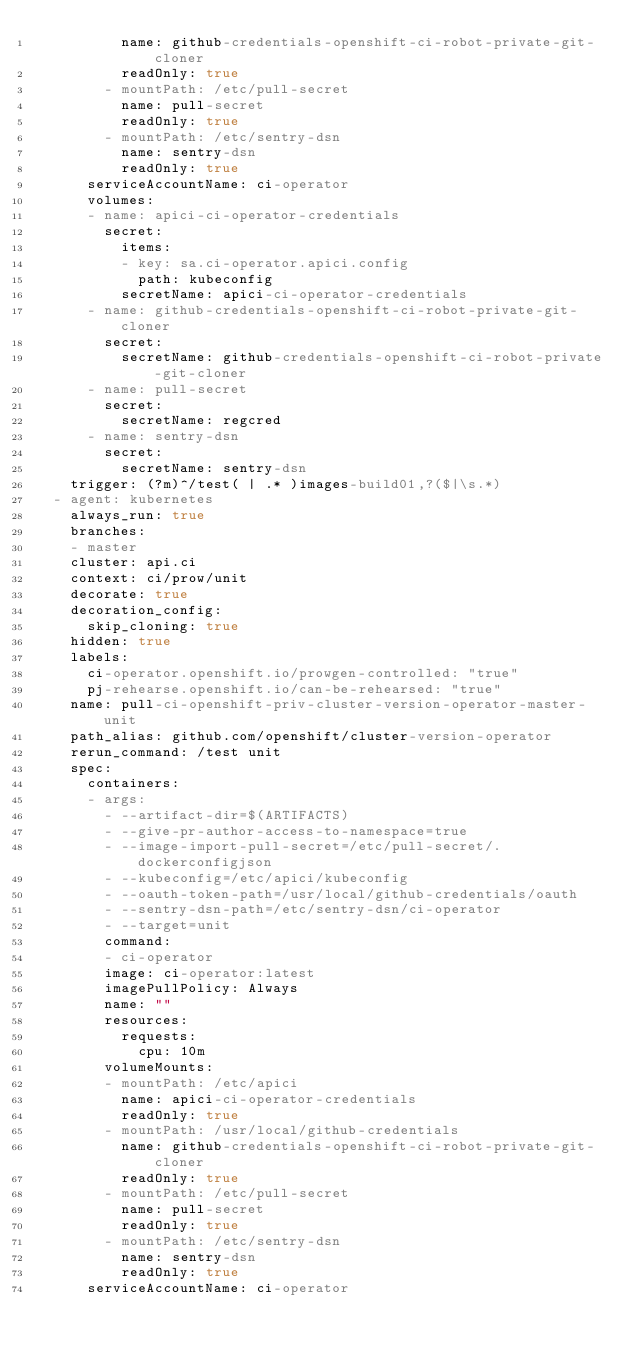Convert code to text. <code><loc_0><loc_0><loc_500><loc_500><_YAML_>          name: github-credentials-openshift-ci-robot-private-git-cloner
          readOnly: true
        - mountPath: /etc/pull-secret
          name: pull-secret
          readOnly: true
        - mountPath: /etc/sentry-dsn
          name: sentry-dsn
          readOnly: true
      serviceAccountName: ci-operator
      volumes:
      - name: apici-ci-operator-credentials
        secret:
          items:
          - key: sa.ci-operator.apici.config
            path: kubeconfig
          secretName: apici-ci-operator-credentials
      - name: github-credentials-openshift-ci-robot-private-git-cloner
        secret:
          secretName: github-credentials-openshift-ci-robot-private-git-cloner
      - name: pull-secret
        secret:
          secretName: regcred
      - name: sentry-dsn
        secret:
          secretName: sentry-dsn
    trigger: (?m)^/test( | .* )images-build01,?($|\s.*)
  - agent: kubernetes
    always_run: true
    branches:
    - master
    cluster: api.ci
    context: ci/prow/unit
    decorate: true
    decoration_config:
      skip_cloning: true
    hidden: true
    labels:
      ci-operator.openshift.io/prowgen-controlled: "true"
      pj-rehearse.openshift.io/can-be-rehearsed: "true"
    name: pull-ci-openshift-priv-cluster-version-operator-master-unit
    path_alias: github.com/openshift/cluster-version-operator
    rerun_command: /test unit
    spec:
      containers:
      - args:
        - --artifact-dir=$(ARTIFACTS)
        - --give-pr-author-access-to-namespace=true
        - --image-import-pull-secret=/etc/pull-secret/.dockerconfigjson
        - --kubeconfig=/etc/apici/kubeconfig
        - --oauth-token-path=/usr/local/github-credentials/oauth
        - --sentry-dsn-path=/etc/sentry-dsn/ci-operator
        - --target=unit
        command:
        - ci-operator
        image: ci-operator:latest
        imagePullPolicy: Always
        name: ""
        resources:
          requests:
            cpu: 10m
        volumeMounts:
        - mountPath: /etc/apici
          name: apici-ci-operator-credentials
          readOnly: true
        - mountPath: /usr/local/github-credentials
          name: github-credentials-openshift-ci-robot-private-git-cloner
          readOnly: true
        - mountPath: /etc/pull-secret
          name: pull-secret
          readOnly: true
        - mountPath: /etc/sentry-dsn
          name: sentry-dsn
          readOnly: true
      serviceAccountName: ci-operator</code> 